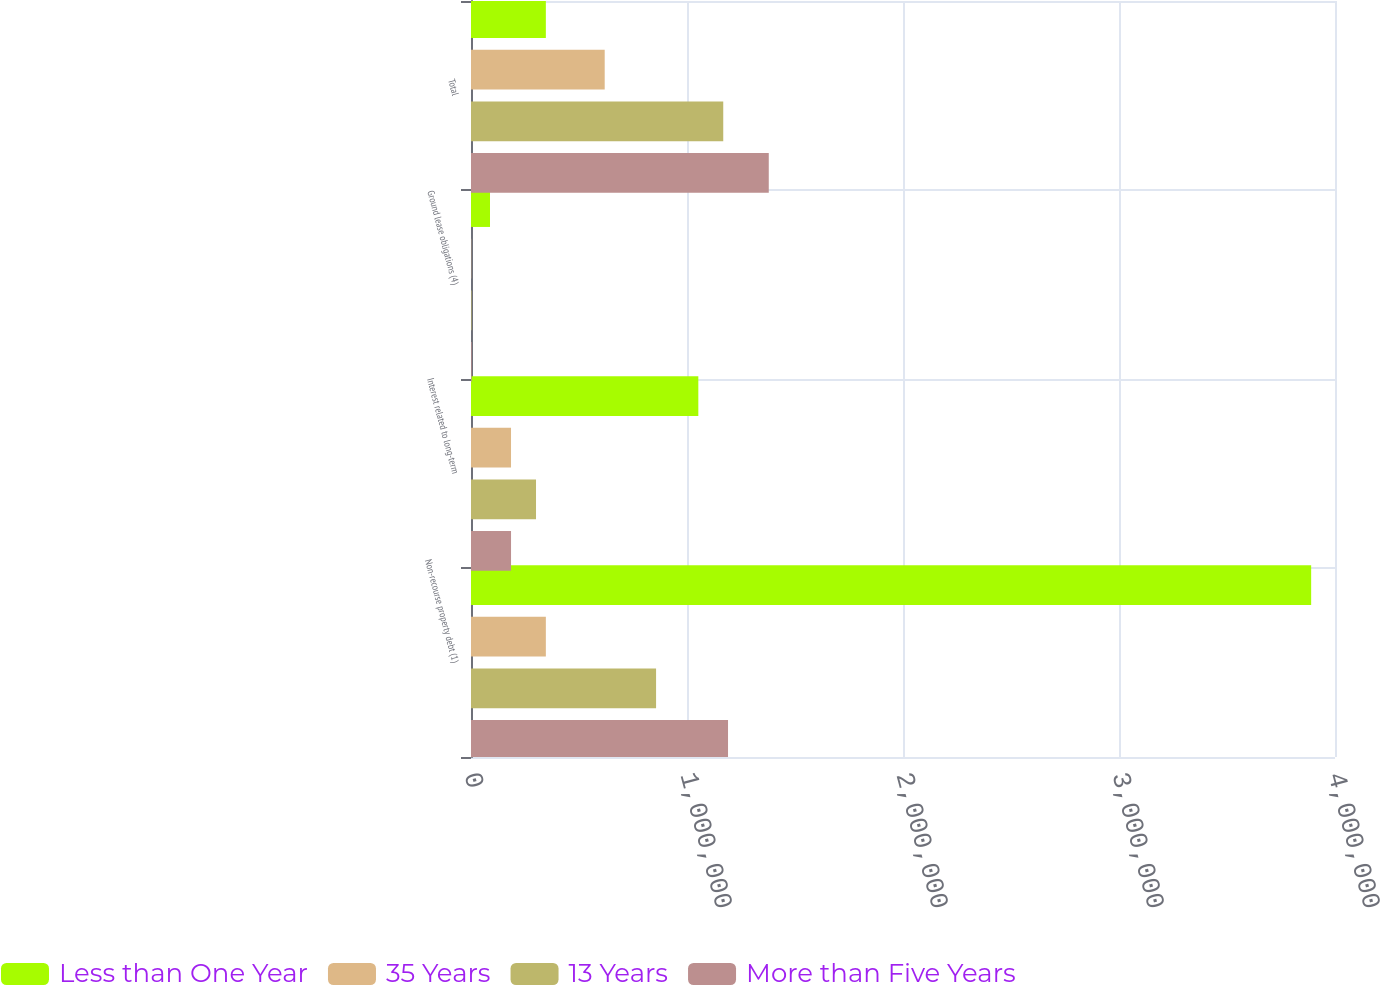<chart> <loc_0><loc_0><loc_500><loc_500><stacked_bar_chart><ecel><fcel>Non-recourse property debt (1)<fcel>Interest related to long-term<fcel>Ground lease obligations (4)<fcel>Total<nl><fcel>Less than One Year<fcel>3.88965e+06<fcel>1.05244e+06<fcel>88057<fcel>346519<nl><fcel>35 Years<fcel>346519<fcel>185303<fcel>1093<fcel>618972<nl><fcel>13 Years<fcel>856830<fcel>300991<fcel>2486<fcel>1.16782e+06<nl><fcel>More than Five Years<fcel>1.18994e+06<fcel>185360<fcel>3094<fcel>1.37855e+06<nl></chart> 